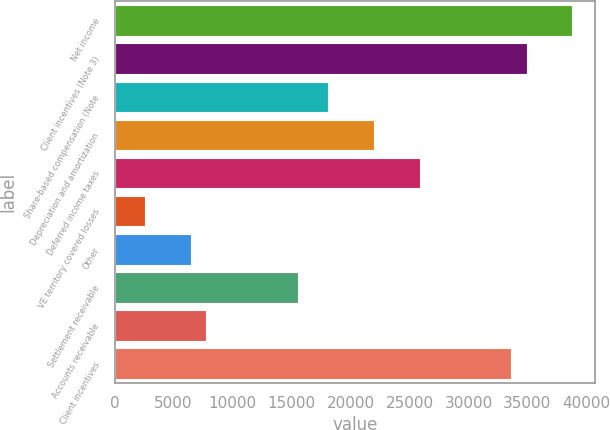Convert chart to OTSL. <chart><loc_0><loc_0><loc_500><loc_500><bar_chart><fcel>Net income<fcel>Client incentives (Note 3)<fcel>Share-based compensation (Note<fcel>Depreciation and amortization<fcel>Deferred income taxes<fcel>VE territory covered losses<fcel>Other<fcel>Settlement receivable<fcel>Accounts receivable<fcel>Client incentives<nl><fcel>38819<fcel>34937.3<fcel>18116.6<fcel>21998.3<fcel>25880<fcel>2589.8<fcel>6471.5<fcel>15528.8<fcel>7765.4<fcel>33643.4<nl></chart> 